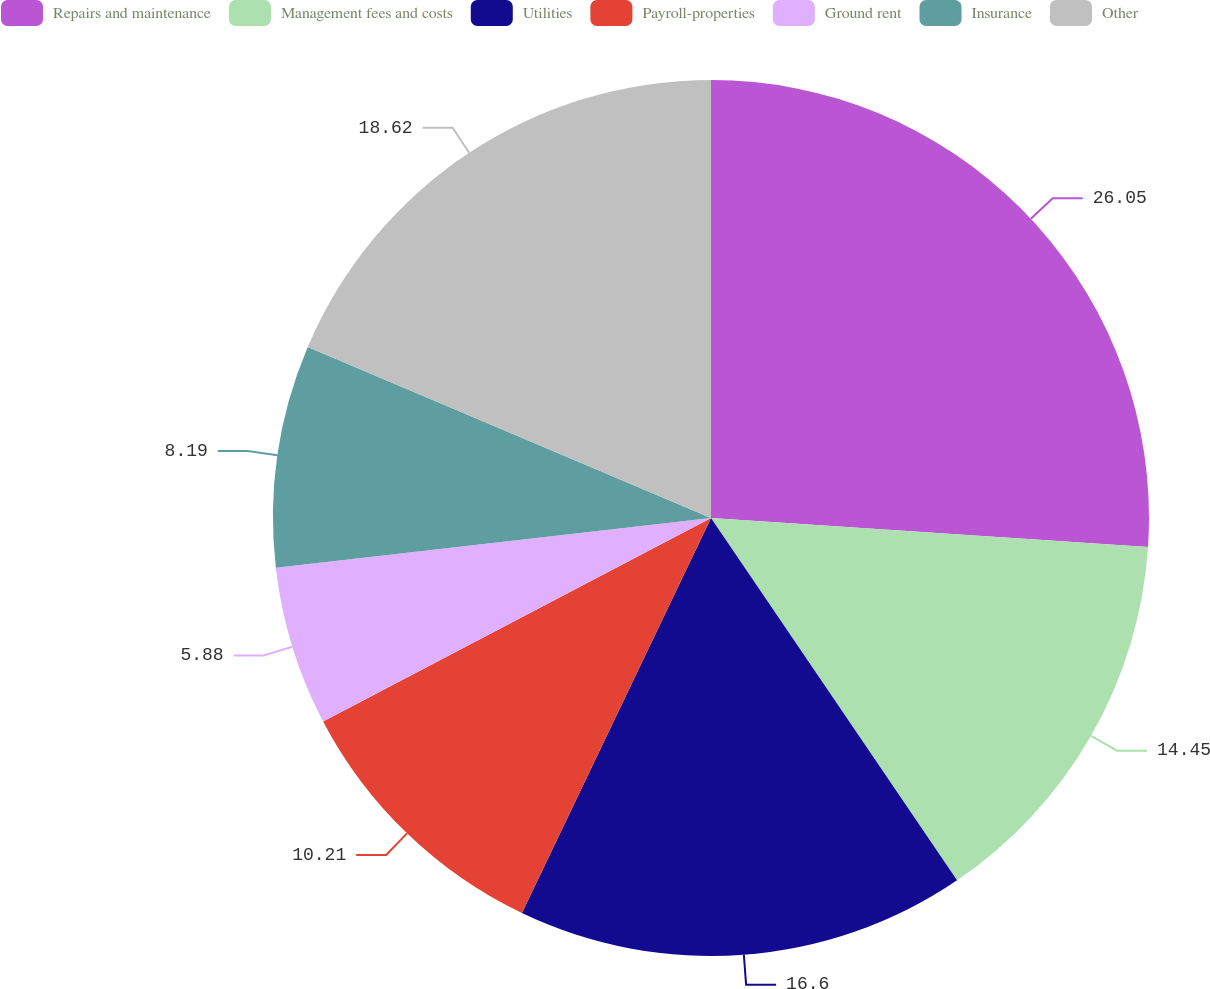Convert chart. <chart><loc_0><loc_0><loc_500><loc_500><pie_chart><fcel>Repairs and maintenance<fcel>Management fees and costs<fcel>Utilities<fcel>Payroll-properties<fcel>Ground rent<fcel>Insurance<fcel>Other<nl><fcel>26.06%<fcel>14.45%<fcel>16.6%<fcel>10.21%<fcel>5.88%<fcel>8.19%<fcel>18.62%<nl></chart> 